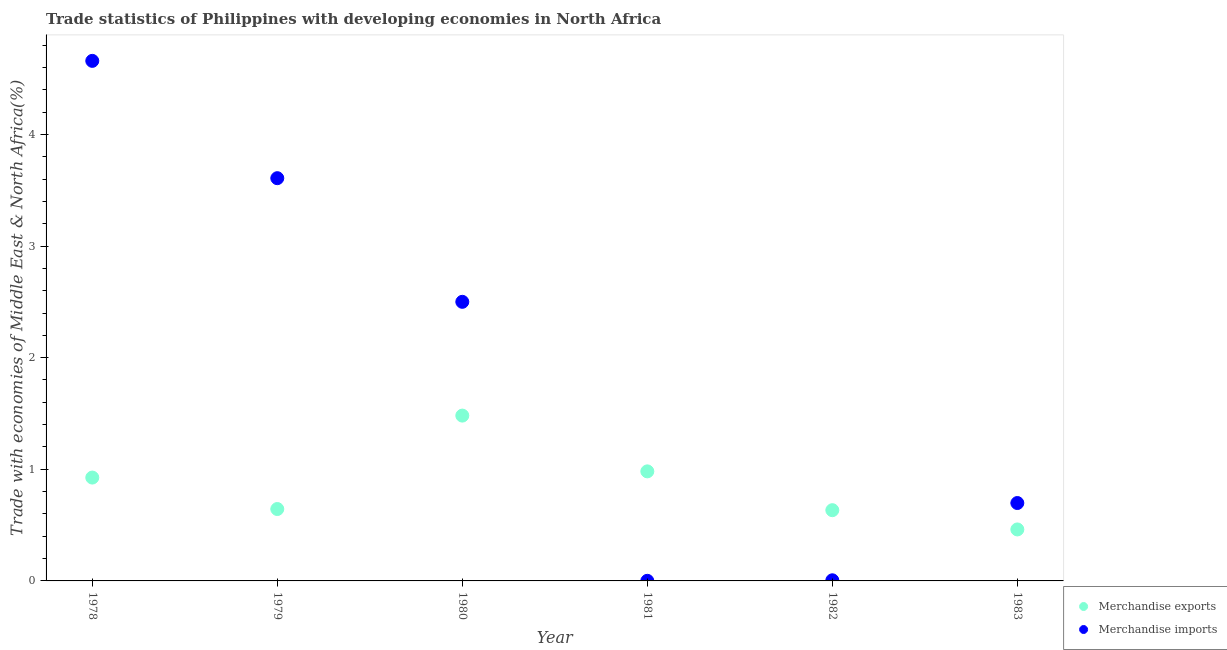Is the number of dotlines equal to the number of legend labels?
Offer a terse response. Yes. What is the merchandise exports in 1979?
Your response must be concise. 0.64. Across all years, what is the maximum merchandise imports?
Your response must be concise. 4.66. Across all years, what is the minimum merchandise exports?
Offer a very short reply. 0.46. In which year was the merchandise exports maximum?
Your answer should be very brief. 1980. In which year was the merchandise imports minimum?
Provide a short and direct response. 1981. What is the total merchandise imports in the graph?
Give a very brief answer. 11.47. What is the difference between the merchandise exports in 1980 and that in 1982?
Keep it short and to the point. 0.85. What is the difference between the merchandise exports in 1979 and the merchandise imports in 1981?
Ensure brevity in your answer.  0.64. What is the average merchandise exports per year?
Your response must be concise. 0.85. In the year 1983, what is the difference between the merchandise exports and merchandise imports?
Ensure brevity in your answer.  -0.24. In how many years, is the merchandise exports greater than 0.2 %?
Your response must be concise. 6. What is the ratio of the merchandise imports in 1982 to that in 1983?
Make the answer very short. 0.01. Is the merchandise imports in 1978 less than that in 1979?
Provide a succinct answer. No. What is the difference between the highest and the second highest merchandise imports?
Your answer should be compact. 1.05. What is the difference between the highest and the lowest merchandise exports?
Your answer should be very brief. 1.02. Does the merchandise exports monotonically increase over the years?
Give a very brief answer. No. How many dotlines are there?
Your answer should be very brief. 2. Are the values on the major ticks of Y-axis written in scientific E-notation?
Your answer should be compact. No. How many legend labels are there?
Provide a short and direct response. 2. How are the legend labels stacked?
Make the answer very short. Vertical. What is the title of the graph?
Give a very brief answer. Trade statistics of Philippines with developing economies in North Africa. Does "Arms imports" appear as one of the legend labels in the graph?
Your answer should be very brief. No. What is the label or title of the X-axis?
Your response must be concise. Year. What is the label or title of the Y-axis?
Make the answer very short. Trade with economies of Middle East & North Africa(%). What is the Trade with economies of Middle East & North Africa(%) of Merchandise exports in 1978?
Your answer should be very brief. 0.93. What is the Trade with economies of Middle East & North Africa(%) in Merchandise imports in 1978?
Offer a very short reply. 4.66. What is the Trade with economies of Middle East & North Africa(%) in Merchandise exports in 1979?
Make the answer very short. 0.64. What is the Trade with economies of Middle East & North Africa(%) of Merchandise imports in 1979?
Provide a succinct answer. 3.61. What is the Trade with economies of Middle East & North Africa(%) of Merchandise exports in 1980?
Give a very brief answer. 1.48. What is the Trade with economies of Middle East & North Africa(%) of Merchandise imports in 1980?
Your response must be concise. 2.5. What is the Trade with economies of Middle East & North Africa(%) in Merchandise exports in 1981?
Offer a very short reply. 0.98. What is the Trade with economies of Middle East & North Africa(%) in Merchandise imports in 1981?
Provide a succinct answer. 0. What is the Trade with economies of Middle East & North Africa(%) in Merchandise exports in 1982?
Offer a terse response. 0.63. What is the Trade with economies of Middle East & North Africa(%) in Merchandise imports in 1982?
Give a very brief answer. 0.01. What is the Trade with economies of Middle East & North Africa(%) in Merchandise exports in 1983?
Provide a short and direct response. 0.46. What is the Trade with economies of Middle East & North Africa(%) in Merchandise imports in 1983?
Make the answer very short. 0.7. Across all years, what is the maximum Trade with economies of Middle East & North Africa(%) in Merchandise exports?
Your answer should be very brief. 1.48. Across all years, what is the maximum Trade with economies of Middle East & North Africa(%) of Merchandise imports?
Provide a short and direct response. 4.66. Across all years, what is the minimum Trade with economies of Middle East & North Africa(%) of Merchandise exports?
Your response must be concise. 0.46. Across all years, what is the minimum Trade with economies of Middle East & North Africa(%) of Merchandise imports?
Give a very brief answer. 0. What is the total Trade with economies of Middle East & North Africa(%) in Merchandise exports in the graph?
Offer a terse response. 5.13. What is the total Trade with economies of Middle East & North Africa(%) in Merchandise imports in the graph?
Keep it short and to the point. 11.47. What is the difference between the Trade with economies of Middle East & North Africa(%) of Merchandise exports in 1978 and that in 1979?
Ensure brevity in your answer.  0.28. What is the difference between the Trade with economies of Middle East & North Africa(%) of Merchandise imports in 1978 and that in 1979?
Your response must be concise. 1.05. What is the difference between the Trade with economies of Middle East & North Africa(%) of Merchandise exports in 1978 and that in 1980?
Offer a very short reply. -0.56. What is the difference between the Trade with economies of Middle East & North Africa(%) of Merchandise imports in 1978 and that in 1980?
Your answer should be very brief. 2.16. What is the difference between the Trade with economies of Middle East & North Africa(%) in Merchandise exports in 1978 and that in 1981?
Your answer should be very brief. -0.06. What is the difference between the Trade with economies of Middle East & North Africa(%) in Merchandise imports in 1978 and that in 1981?
Your answer should be very brief. 4.66. What is the difference between the Trade with economies of Middle East & North Africa(%) in Merchandise exports in 1978 and that in 1982?
Provide a short and direct response. 0.29. What is the difference between the Trade with economies of Middle East & North Africa(%) of Merchandise imports in 1978 and that in 1982?
Offer a terse response. 4.65. What is the difference between the Trade with economies of Middle East & North Africa(%) in Merchandise exports in 1978 and that in 1983?
Your response must be concise. 0.46. What is the difference between the Trade with economies of Middle East & North Africa(%) in Merchandise imports in 1978 and that in 1983?
Offer a very short reply. 3.96. What is the difference between the Trade with economies of Middle East & North Africa(%) of Merchandise exports in 1979 and that in 1980?
Your answer should be compact. -0.84. What is the difference between the Trade with economies of Middle East & North Africa(%) in Merchandise imports in 1979 and that in 1980?
Offer a terse response. 1.11. What is the difference between the Trade with economies of Middle East & North Africa(%) in Merchandise exports in 1979 and that in 1981?
Provide a short and direct response. -0.34. What is the difference between the Trade with economies of Middle East & North Africa(%) in Merchandise imports in 1979 and that in 1981?
Your answer should be compact. 3.61. What is the difference between the Trade with economies of Middle East & North Africa(%) in Merchandise exports in 1979 and that in 1982?
Make the answer very short. 0.01. What is the difference between the Trade with economies of Middle East & North Africa(%) of Merchandise imports in 1979 and that in 1982?
Offer a very short reply. 3.6. What is the difference between the Trade with economies of Middle East & North Africa(%) in Merchandise exports in 1979 and that in 1983?
Your response must be concise. 0.18. What is the difference between the Trade with economies of Middle East & North Africa(%) in Merchandise imports in 1979 and that in 1983?
Offer a very short reply. 2.91. What is the difference between the Trade with economies of Middle East & North Africa(%) of Merchandise exports in 1980 and that in 1981?
Offer a terse response. 0.5. What is the difference between the Trade with economies of Middle East & North Africa(%) of Merchandise imports in 1980 and that in 1981?
Offer a very short reply. 2.5. What is the difference between the Trade with economies of Middle East & North Africa(%) in Merchandise exports in 1980 and that in 1982?
Offer a very short reply. 0.85. What is the difference between the Trade with economies of Middle East & North Africa(%) of Merchandise imports in 1980 and that in 1982?
Keep it short and to the point. 2.49. What is the difference between the Trade with economies of Middle East & North Africa(%) of Merchandise exports in 1980 and that in 1983?
Your answer should be very brief. 1.02. What is the difference between the Trade with economies of Middle East & North Africa(%) in Merchandise imports in 1980 and that in 1983?
Your answer should be compact. 1.8. What is the difference between the Trade with economies of Middle East & North Africa(%) in Merchandise exports in 1981 and that in 1982?
Offer a terse response. 0.35. What is the difference between the Trade with economies of Middle East & North Africa(%) in Merchandise imports in 1981 and that in 1982?
Offer a terse response. -0. What is the difference between the Trade with economies of Middle East & North Africa(%) of Merchandise exports in 1981 and that in 1983?
Provide a succinct answer. 0.52. What is the difference between the Trade with economies of Middle East & North Africa(%) in Merchandise imports in 1981 and that in 1983?
Keep it short and to the point. -0.7. What is the difference between the Trade with economies of Middle East & North Africa(%) of Merchandise exports in 1982 and that in 1983?
Provide a short and direct response. 0.17. What is the difference between the Trade with economies of Middle East & North Africa(%) of Merchandise imports in 1982 and that in 1983?
Provide a succinct answer. -0.69. What is the difference between the Trade with economies of Middle East & North Africa(%) in Merchandise exports in 1978 and the Trade with economies of Middle East & North Africa(%) in Merchandise imports in 1979?
Give a very brief answer. -2.68. What is the difference between the Trade with economies of Middle East & North Africa(%) in Merchandise exports in 1978 and the Trade with economies of Middle East & North Africa(%) in Merchandise imports in 1980?
Provide a succinct answer. -1.57. What is the difference between the Trade with economies of Middle East & North Africa(%) in Merchandise exports in 1978 and the Trade with economies of Middle East & North Africa(%) in Merchandise imports in 1981?
Offer a terse response. 0.92. What is the difference between the Trade with economies of Middle East & North Africa(%) in Merchandise exports in 1978 and the Trade with economies of Middle East & North Africa(%) in Merchandise imports in 1982?
Make the answer very short. 0.92. What is the difference between the Trade with economies of Middle East & North Africa(%) of Merchandise exports in 1978 and the Trade with economies of Middle East & North Africa(%) of Merchandise imports in 1983?
Make the answer very short. 0.23. What is the difference between the Trade with economies of Middle East & North Africa(%) of Merchandise exports in 1979 and the Trade with economies of Middle East & North Africa(%) of Merchandise imports in 1980?
Your response must be concise. -1.86. What is the difference between the Trade with economies of Middle East & North Africa(%) in Merchandise exports in 1979 and the Trade with economies of Middle East & North Africa(%) in Merchandise imports in 1981?
Provide a short and direct response. 0.64. What is the difference between the Trade with economies of Middle East & North Africa(%) of Merchandise exports in 1979 and the Trade with economies of Middle East & North Africa(%) of Merchandise imports in 1982?
Provide a succinct answer. 0.64. What is the difference between the Trade with economies of Middle East & North Africa(%) in Merchandise exports in 1979 and the Trade with economies of Middle East & North Africa(%) in Merchandise imports in 1983?
Offer a terse response. -0.05. What is the difference between the Trade with economies of Middle East & North Africa(%) of Merchandise exports in 1980 and the Trade with economies of Middle East & North Africa(%) of Merchandise imports in 1981?
Offer a very short reply. 1.48. What is the difference between the Trade with economies of Middle East & North Africa(%) in Merchandise exports in 1980 and the Trade with economies of Middle East & North Africa(%) in Merchandise imports in 1982?
Give a very brief answer. 1.48. What is the difference between the Trade with economies of Middle East & North Africa(%) of Merchandise exports in 1980 and the Trade with economies of Middle East & North Africa(%) of Merchandise imports in 1983?
Make the answer very short. 0.78. What is the difference between the Trade with economies of Middle East & North Africa(%) in Merchandise exports in 1981 and the Trade with economies of Middle East & North Africa(%) in Merchandise imports in 1982?
Give a very brief answer. 0.98. What is the difference between the Trade with economies of Middle East & North Africa(%) in Merchandise exports in 1981 and the Trade with economies of Middle East & North Africa(%) in Merchandise imports in 1983?
Ensure brevity in your answer.  0.28. What is the difference between the Trade with economies of Middle East & North Africa(%) in Merchandise exports in 1982 and the Trade with economies of Middle East & North Africa(%) in Merchandise imports in 1983?
Your answer should be very brief. -0.06. What is the average Trade with economies of Middle East & North Africa(%) in Merchandise exports per year?
Your response must be concise. 0.85. What is the average Trade with economies of Middle East & North Africa(%) of Merchandise imports per year?
Provide a short and direct response. 1.91. In the year 1978, what is the difference between the Trade with economies of Middle East & North Africa(%) in Merchandise exports and Trade with economies of Middle East & North Africa(%) in Merchandise imports?
Offer a terse response. -3.73. In the year 1979, what is the difference between the Trade with economies of Middle East & North Africa(%) in Merchandise exports and Trade with economies of Middle East & North Africa(%) in Merchandise imports?
Your response must be concise. -2.96. In the year 1980, what is the difference between the Trade with economies of Middle East & North Africa(%) in Merchandise exports and Trade with economies of Middle East & North Africa(%) in Merchandise imports?
Provide a succinct answer. -1.02. In the year 1981, what is the difference between the Trade with economies of Middle East & North Africa(%) of Merchandise exports and Trade with economies of Middle East & North Africa(%) of Merchandise imports?
Keep it short and to the point. 0.98. In the year 1982, what is the difference between the Trade with economies of Middle East & North Africa(%) of Merchandise exports and Trade with economies of Middle East & North Africa(%) of Merchandise imports?
Provide a short and direct response. 0.63. In the year 1983, what is the difference between the Trade with economies of Middle East & North Africa(%) in Merchandise exports and Trade with economies of Middle East & North Africa(%) in Merchandise imports?
Offer a very short reply. -0.24. What is the ratio of the Trade with economies of Middle East & North Africa(%) in Merchandise exports in 1978 to that in 1979?
Ensure brevity in your answer.  1.44. What is the ratio of the Trade with economies of Middle East & North Africa(%) of Merchandise imports in 1978 to that in 1979?
Your response must be concise. 1.29. What is the ratio of the Trade with economies of Middle East & North Africa(%) of Merchandise exports in 1978 to that in 1980?
Provide a short and direct response. 0.63. What is the ratio of the Trade with economies of Middle East & North Africa(%) in Merchandise imports in 1978 to that in 1980?
Offer a terse response. 1.86. What is the ratio of the Trade with economies of Middle East & North Africa(%) in Merchandise exports in 1978 to that in 1981?
Keep it short and to the point. 0.94. What is the ratio of the Trade with economies of Middle East & North Africa(%) of Merchandise imports in 1978 to that in 1981?
Provide a succinct answer. 4936.49. What is the ratio of the Trade with economies of Middle East & North Africa(%) of Merchandise exports in 1978 to that in 1982?
Your answer should be compact. 1.46. What is the ratio of the Trade with economies of Middle East & North Africa(%) of Merchandise imports in 1978 to that in 1982?
Provide a succinct answer. 818.96. What is the ratio of the Trade with economies of Middle East & North Africa(%) of Merchandise exports in 1978 to that in 1983?
Your answer should be very brief. 2.01. What is the ratio of the Trade with economies of Middle East & North Africa(%) in Merchandise imports in 1978 to that in 1983?
Your answer should be very brief. 6.68. What is the ratio of the Trade with economies of Middle East & North Africa(%) in Merchandise exports in 1979 to that in 1980?
Give a very brief answer. 0.43. What is the ratio of the Trade with economies of Middle East & North Africa(%) in Merchandise imports in 1979 to that in 1980?
Offer a terse response. 1.44. What is the ratio of the Trade with economies of Middle East & North Africa(%) of Merchandise exports in 1979 to that in 1981?
Your answer should be compact. 0.66. What is the ratio of the Trade with economies of Middle East & North Africa(%) of Merchandise imports in 1979 to that in 1981?
Your answer should be very brief. 3822.92. What is the ratio of the Trade with economies of Middle East & North Africa(%) of Merchandise exports in 1979 to that in 1982?
Offer a terse response. 1.02. What is the ratio of the Trade with economies of Middle East & North Africa(%) of Merchandise imports in 1979 to that in 1982?
Offer a very short reply. 634.22. What is the ratio of the Trade with economies of Middle East & North Africa(%) of Merchandise exports in 1979 to that in 1983?
Offer a terse response. 1.4. What is the ratio of the Trade with economies of Middle East & North Africa(%) of Merchandise imports in 1979 to that in 1983?
Provide a succinct answer. 5.17. What is the ratio of the Trade with economies of Middle East & North Africa(%) in Merchandise exports in 1980 to that in 1981?
Ensure brevity in your answer.  1.51. What is the ratio of the Trade with economies of Middle East & North Africa(%) in Merchandise imports in 1980 to that in 1981?
Offer a terse response. 2649.26. What is the ratio of the Trade with economies of Middle East & North Africa(%) in Merchandise exports in 1980 to that in 1982?
Ensure brevity in your answer.  2.34. What is the ratio of the Trade with economies of Middle East & North Africa(%) in Merchandise imports in 1980 to that in 1982?
Keep it short and to the point. 439.51. What is the ratio of the Trade with economies of Middle East & North Africa(%) of Merchandise exports in 1980 to that in 1983?
Keep it short and to the point. 3.21. What is the ratio of the Trade with economies of Middle East & North Africa(%) of Merchandise imports in 1980 to that in 1983?
Your answer should be compact. 3.58. What is the ratio of the Trade with economies of Middle East & North Africa(%) in Merchandise exports in 1981 to that in 1982?
Provide a short and direct response. 1.55. What is the ratio of the Trade with economies of Middle East & North Africa(%) of Merchandise imports in 1981 to that in 1982?
Your response must be concise. 0.17. What is the ratio of the Trade with economies of Middle East & North Africa(%) in Merchandise exports in 1981 to that in 1983?
Provide a short and direct response. 2.13. What is the ratio of the Trade with economies of Middle East & North Africa(%) in Merchandise imports in 1981 to that in 1983?
Make the answer very short. 0. What is the ratio of the Trade with economies of Middle East & North Africa(%) in Merchandise exports in 1982 to that in 1983?
Give a very brief answer. 1.37. What is the ratio of the Trade with economies of Middle East & North Africa(%) of Merchandise imports in 1982 to that in 1983?
Your response must be concise. 0.01. What is the difference between the highest and the second highest Trade with economies of Middle East & North Africa(%) in Merchandise exports?
Provide a short and direct response. 0.5. What is the difference between the highest and the second highest Trade with economies of Middle East & North Africa(%) in Merchandise imports?
Your answer should be compact. 1.05. What is the difference between the highest and the lowest Trade with economies of Middle East & North Africa(%) in Merchandise exports?
Keep it short and to the point. 1.02. What is the difference between the highest and the lowest Trade with economies of Middle East & North Africa(%) in Merchandise imports?
Your response must be concise. 4.66. 